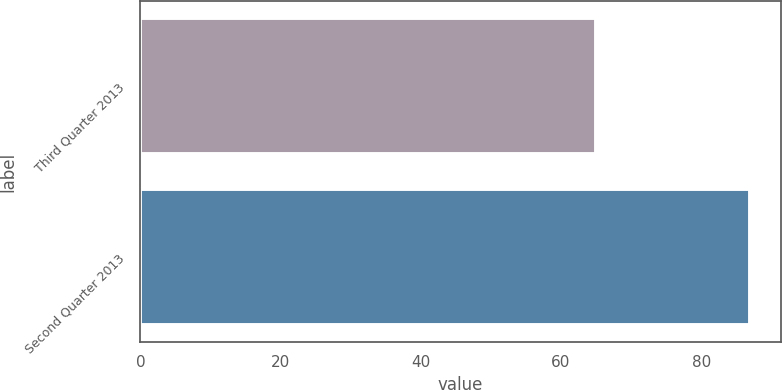<chart> <loc_0><loc_0><loc_500><loc_500><bar_chart><fcel>Third Quarter 2013<fcel>Second Quarter 2013<nl><fcel>65<fcel>87<nl></chart> 